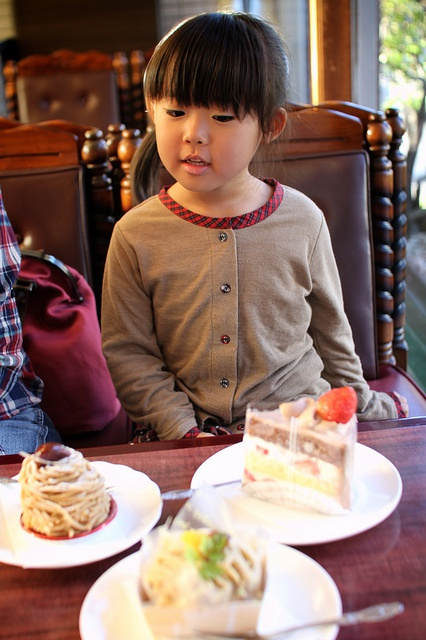Describe the objects in this image and their specific colors. I can see dining table in olive, white, tan, maroon, and brown tones, people in olive, gray, black, darkgray, and maroon tones, chair in olive, black, maroon, gray, and brown tones, chair in olive, black, maroon, and gray tones, and handbag in olive, black, maroon, and brown tones in this image. 